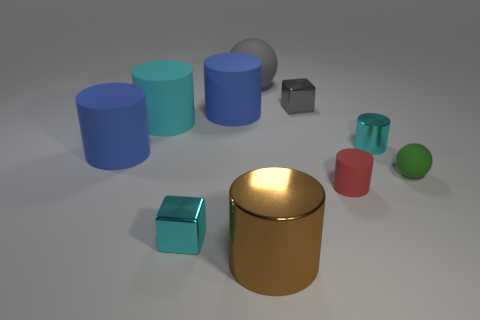There is a large object in front of the green rubber ball; how many large cylinders are in front of it?
Your response must be concise. 0. How many things are either big rubber objects or small green blocks?
Offer a very short reply. 4. Do the tiny red matte thing and the big brown object have the same shape?
Keep it short and to the point. Yes. What is the large sphere made of?
Your response must be concise. Rubber. What number of cyan things are both behind the red rubber cylinder and in front of the tiny green rubber sphere?
Make the answer very short. 0. Do the brown object and the cyan metal block have the same size?
Keep it short and to the point. No. There is a blue thing that is to the right of the cyan shiny block; is it the same size as the tiny cyan block?
Your answer should be very brief. No. There is a small metal cube that is left of the tiny gray thing; what color is it?
Your answer should be very brief. Cyan. How many purple metal balls are there?
Offer a terse response. 0. The small green object that is the same material as the gray ball is what shape?
Provide a short and direct response. Sphere. 